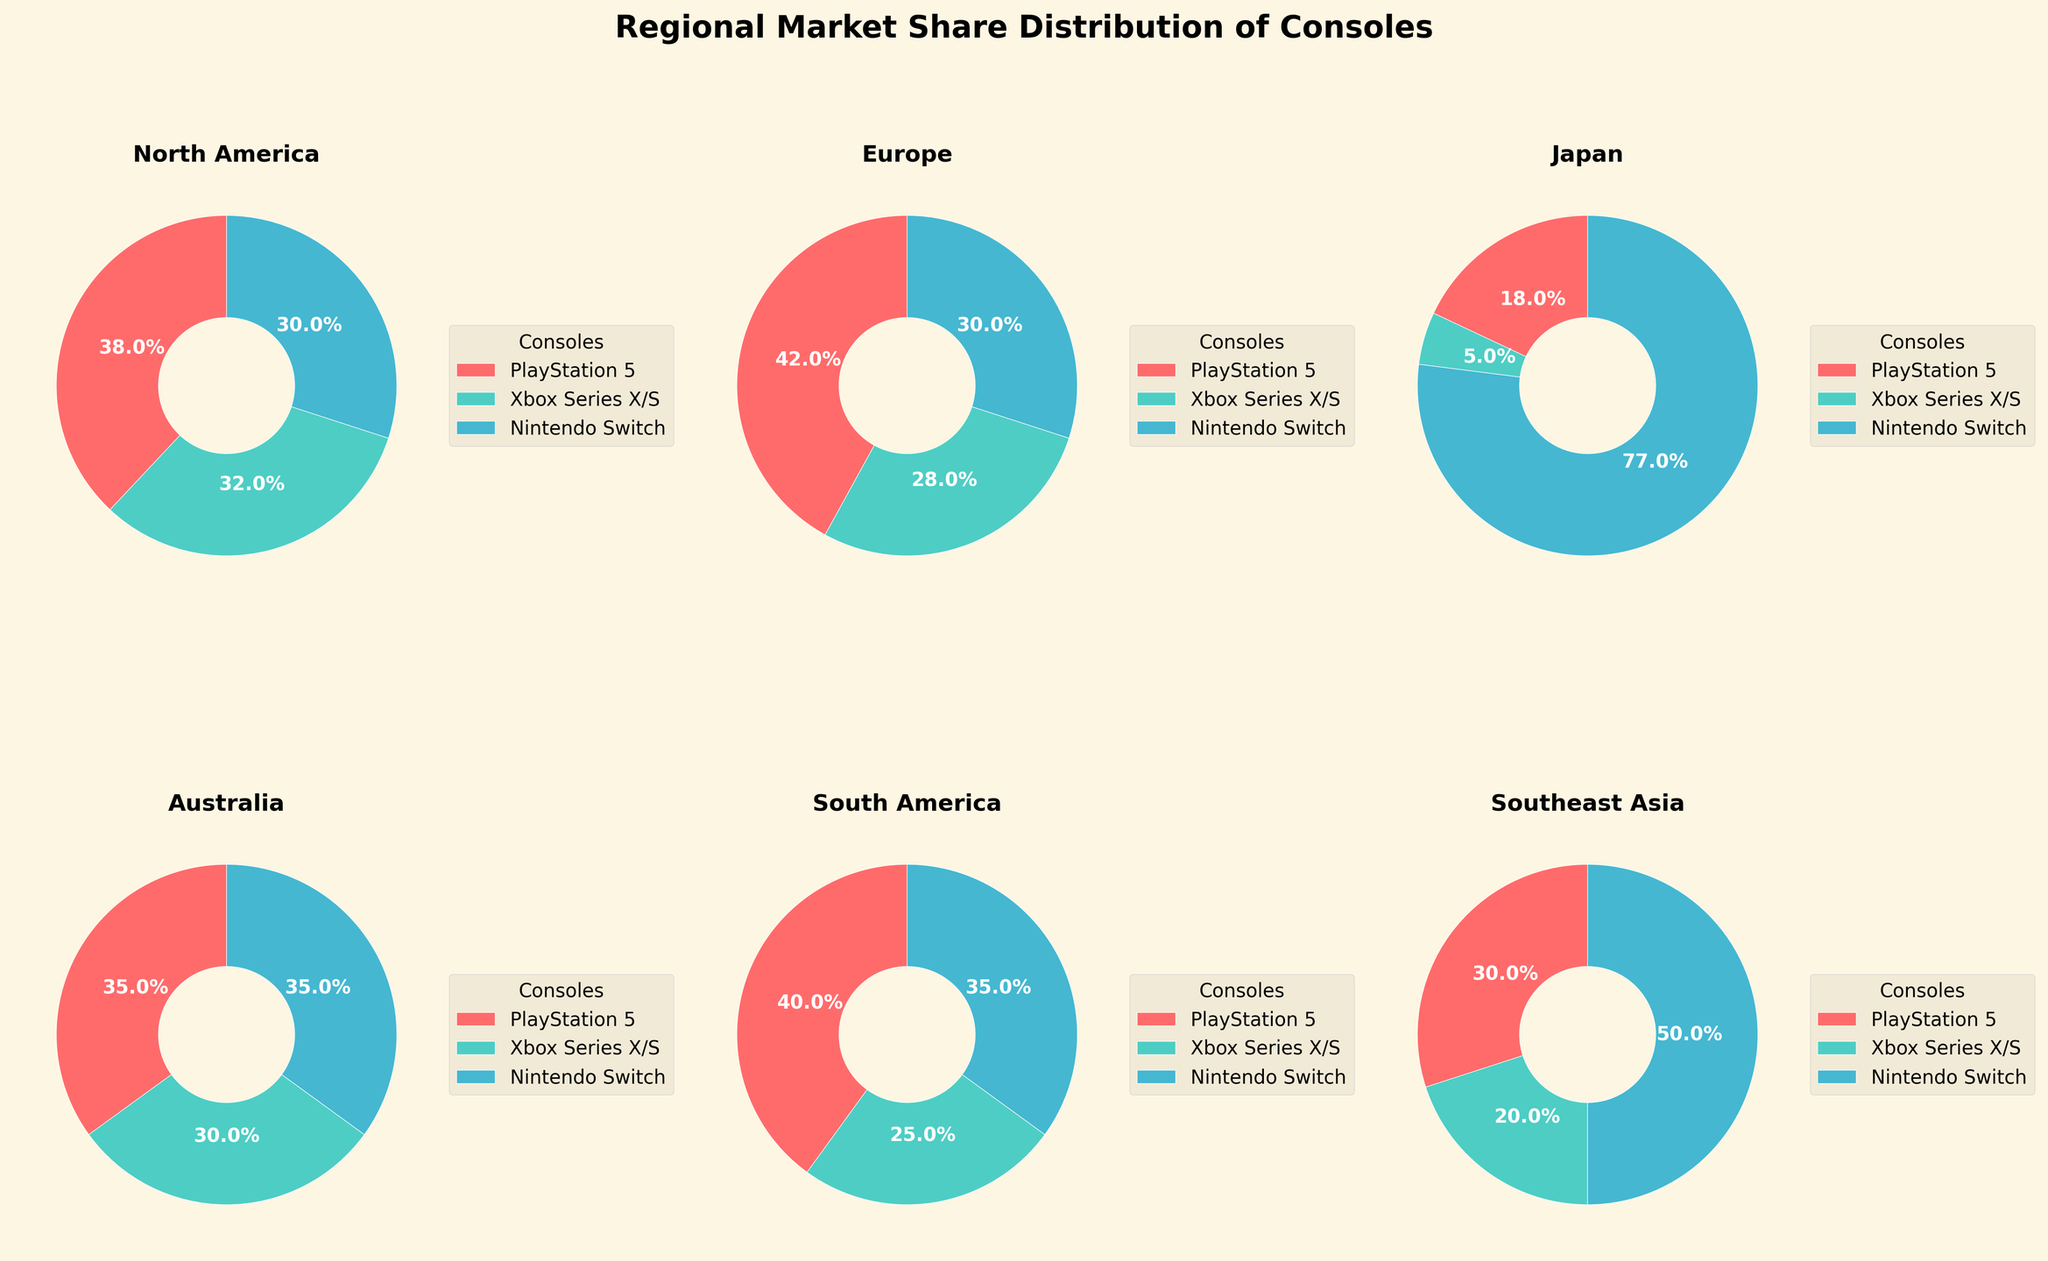What's the total market share percentage of PlayStation 5 in North America and Europe? In North America, PlayStation 5 has a market share of 38%, and in Europe, it has 42%. Add these two values, 38% + 42%, to get the total share.
Answer: 80% Which console has the highest market share in Japan? Look at the Japan subplot, and note the shares. PlayStation 5 has 18%, Xbox Series X/S has 5%, and Nintendo Switch has 77%. The console with the highest share is Nintendo Switch.
Answer: Nintendo Switch Are there any regions where the market share of all three consoles is equal? Examine each subplot for regions with equal shares. In Australia, all consoles (PlayStation 5, Xbox Series X/S, and Nintendo Switch) have the same market share of 35%.
Answer: Australia How does the market share of Xbox Series X/S in Southeast Asia compare to its share in North America? Check the shares for Xbox Series X/S in both regions. In Southeast Asia, it has 20%, and in North America, it has 32%. Hence, the market share in North America is higher.
Answer: North America has a higher market share What's the average market share of the Nintendo Switch across all listed regions? Add up the market shares of the Nintendo Switch in each region (30% + 30% + 77% + 35% + 35% + 50%) and divide by the number of regions (6). The calculation is (30 + 30 + 77 + 35 + 35 + 50) / 6 = 42.83%.
Answer: 42.83% In which region does PlayStation 5 have the lowest market share? Look at the PlayStation 5 slices in each subplot. The smallest slice is in Japan with a market share of 18%.
Answer: Japan Are there any regions where the PlayStation 5 and Xbox Series X/S have a combined market share of more than 70%? Check each subplot for regions where the combined share of PlayStation 5 and Xbox Series X/S exceeds 70%. In North America, PlayStation 5 has 38% and Xbox Series X/S has 32%, summing up to 70%.
Answer: North America What region has the highest combined market share of PlayStation 5 and Nintendo Switch? For each region, sum the market shares of PlayStation 5 and Nintendo Switch. The highest combined share is in Japan with 18% (PlayStation 5) + 77% (Nintendo Switch) = 95%.
Answer: Japan Comparing Europe and South America, which region does the Xbox Series X/S have a higher market share? Look at the Xbox Series X/S share in Europe and South America. In Europe, it is 28%, and in South America, it is 25%. Europe has a higher share.
Answer: Europe 